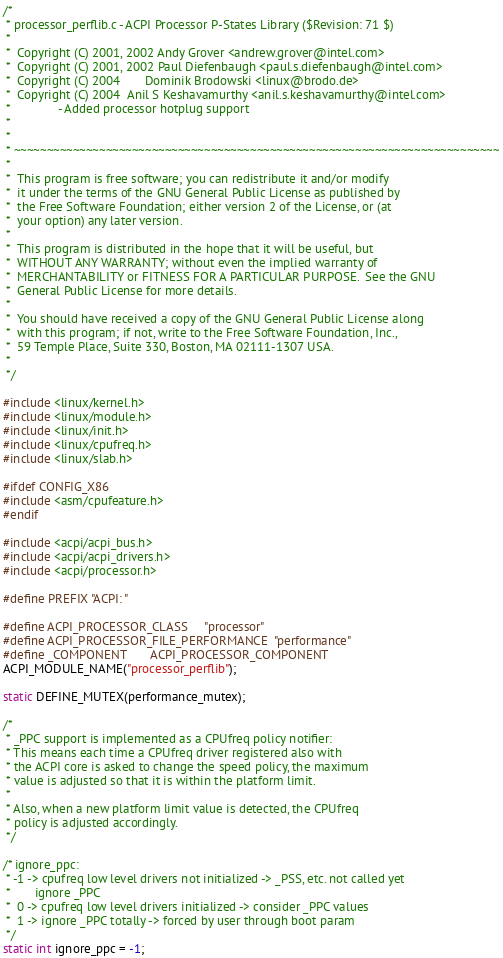<code> <loc_0><loc_0><loc_500><loc_500><_C_>/*
 * processor_perflib.c - ACPI Processor P-States Library ($Revision: 71 $)
 *
 *  Copyright (C) 2001, 2002 Andy Grover <andrew.grover@intel.com>
 *  Copyright (C) 2001, 2002 Paul Diefenbaugh <paul.s.diefenbaugh@intel.com>
 *  Copyright (C) 2004       Dominik Brodowski <linux@brodo.de>
 *  Copyright (C) 2004  Anil S Keshavamurthy <anil.s.keshavamurthy@intel.com>
 *  			- Added processor hotplug support
 *
 *
 * ~~~~~~~~~~~~~~~~~~~~~~~~~~~~~~~~~~~~~~~~~~~~~~~~~~~~~~~~~~~~~~~~~~~~~~~~~~
 *
 *  This program is free software; you can redistribute it and/or modify
 *  it under the terms of the GNU General Public License as published by
 *  the Free Software Foundation; either version 2 of the License, or (at
 *  your option) any later version.
 *
 *  This program is distributed in the hope that it will be useful, but
 *  WITHOUT ANY WARRANTY; without even the implied warranty of
 *  MERCHANTABILITY or FITNESS FOR A PARTICULAR PURPOSE.  See the GNU
 *  General Public License for more details.
 *
 *  You should have received a copy of the GNU General Public License along
 *  with this program; if not, write to the Free Software Foundation, Inc.,
 *  59 Temple Place, Suite 330, Boston, MA 02111-1307 USA.
 *
 */

#include <linux/kernel.h>
#include <linux/module.h>
#include <linux/init.h>
#include <linux/cpufreq.h>
#include <linux/slab.h>

#ifdef CONFIG_X86
#include <asm/cpufeature.h>
#endif

#include <acpi/acpi_bus.h>
#include <acpi/acpi_drivers.h>
#include <acpi/processor.h>

#define PREFIX "ACPI: "

#define ACPI_PROCESSOR_CLASS		"processor"
#define ACPI_PROCESSOR_FILE_PERFORMANCE	"performance"
#define _COMPONENT		ACPI_PROCESSOR_COMPONENT
ACPI_MODULE_NAME("processor_perflib");

static DEFINE_MUTEX(performance_mutex);

/*
 * _PPC support is implemented as a CPUfreq policy notifier:
 * This means each time a CPUfreq driver registered also with
 * the ACPI core is asked to change the speed policy, the maximum
 * value is adjusted so that it is within the platform limit.
 *
 * Also, when a new platform limit value is detected, the CPUfreq
 * policy is adjusted accordingly.
 */

/* ignore_ppc:
 * -1 -> cpufreq low level drivers not initialized -> _PSS, etc. not called yet
 *       ignore _PPC
 *  0 -> cpufreq low level drivers initialized -> consider _PPC values
 *  1 -> ignore _PPC totally -> forced by user through boot param
 */
static int ignore_ppc = -1;</code> 